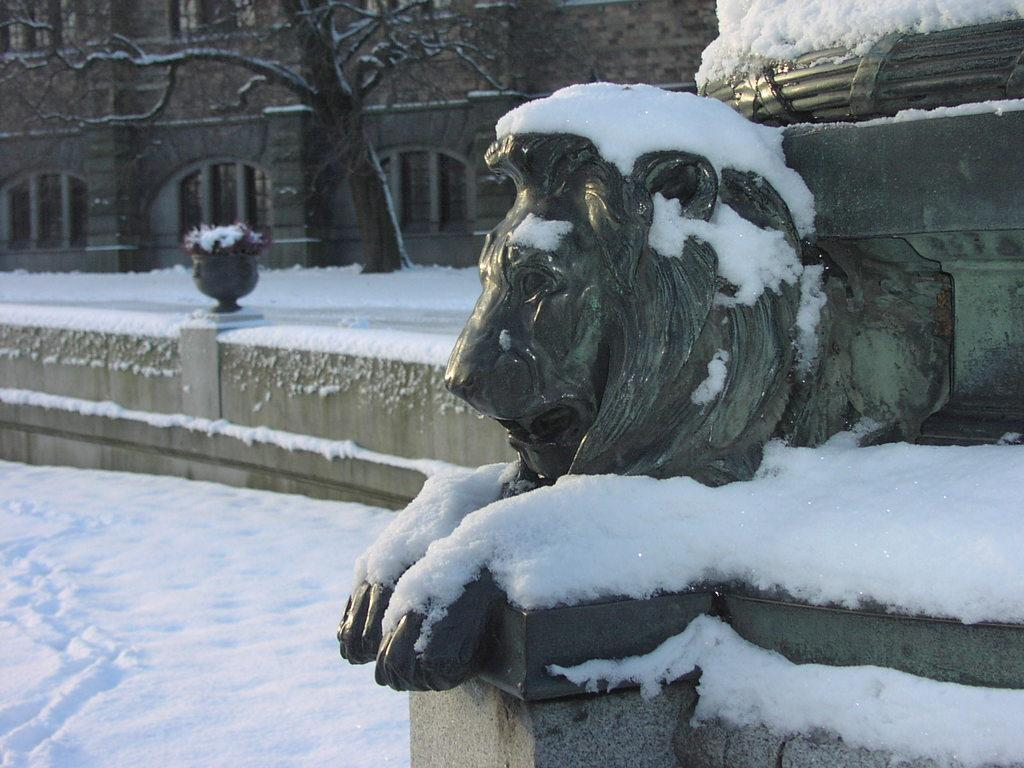What is the main subject in the image? There is a statue in the image. What is the weather condition in the image? There is snow in the image. What can be seen in the background of the image? There is a building, a plant, snow, and a tree in the background of the image. What feature of the building is mentioned in the facts? The building has windows. What type of nerve can be seen in the image? There is no nerve present in the image. What news source is reporting on the statue in the image? There is no news source mentioned in the image. 